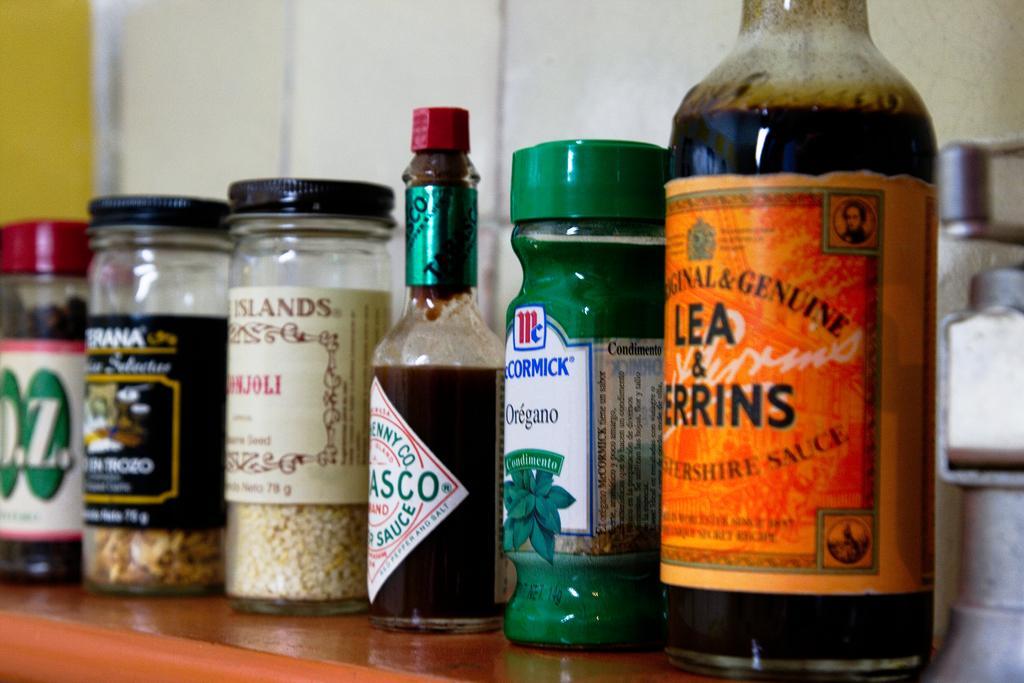Please provide a concise description of this image. There are different bottles kept on a table. And there are labels for this bottles. Inside the bottle there are some items kept. 